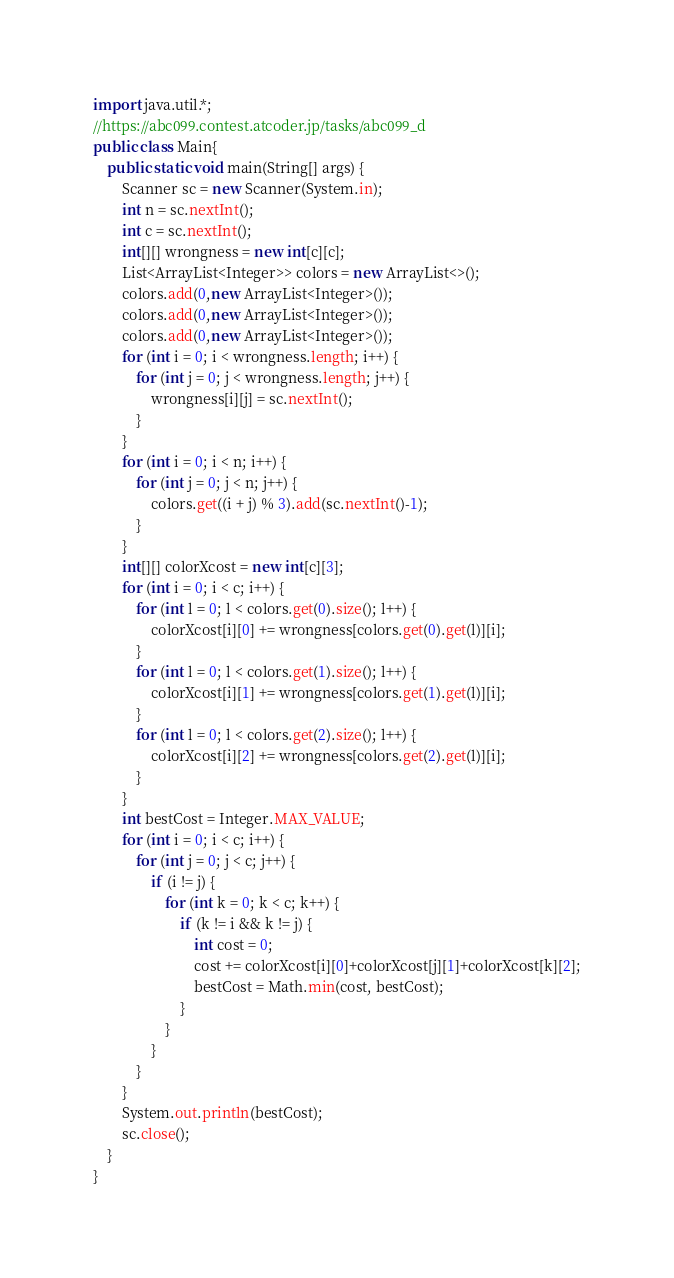<code> <loc_0><loc_0><loc_500><loc_500><_Java_>import java.util.*;
//https://abc099.contest.atcoder.jp/tasks/abc099_d
public class Main{
    public static void main(String[] args) {
        Scanner sc = new Scanner(System.in);
        int n = sc.nextInt();
        int c = sc.nextInt();
        int[][] wrongness = new int[c][c];
        List<ArrayList<Integer>> colors = new ArrayList<>();
        colors.add(0,new ArrayList<Integer>());
        colors.add(0,new ArrayList<Integer>());
        colors.add(0,new ArrayList<Integer>());
        for (int i = 0; i < wrongness.length; i++) {
            for (int j = 0; j < wrongness.length; j++) {
                wrongness[i][j] = sc.nextInt();
            }
        }
        for (int i = 0; i < n; i++) {
            for (int j = 0; j < n; j++) {
                colors.get((i + j) % 3).add(sc.nextInt()-1);
            }
        }
        int[][] colorXcost = new int[c][3];
        for (int i = 0; i < c; i++) {
            for (int l = 0; l < colors.get(0).size(); l++) {
                colorXcost[i][0] += wrongness[colors.get(0).get(l)][i];
            }
            for (int l = 0; l < colors.get(1).size(); l++) {
                colorXcost[i][1] += wrongness[colors.get(1).get(l)][i];
            }
            for (int l = 0; l < colors.get(2).size(); l++) {
                colorXcost[i][2] += wrongness[colors.get(2).get(l)][i];
            }
        }
        int bestCost = Integer.MAX_VALUE;
        for (int i = 0; i < c; i++) {
            for (int j = 0; j < c; j++) {
                if (i != j) {
                    for (int k = 0; k < c; k++) {
                        if (k != i && k != j) {
                            int cost = 0;
                            cost += colorXcost[i][0]+colorXcost[j][1]+colorXcost[k][2];
                            bestCost = Math.min(cost, bestCost);
                        }
                    }
                }
            }
        }
        System.out.println(bestCost);
        sc.close();
    }
}
</code> 